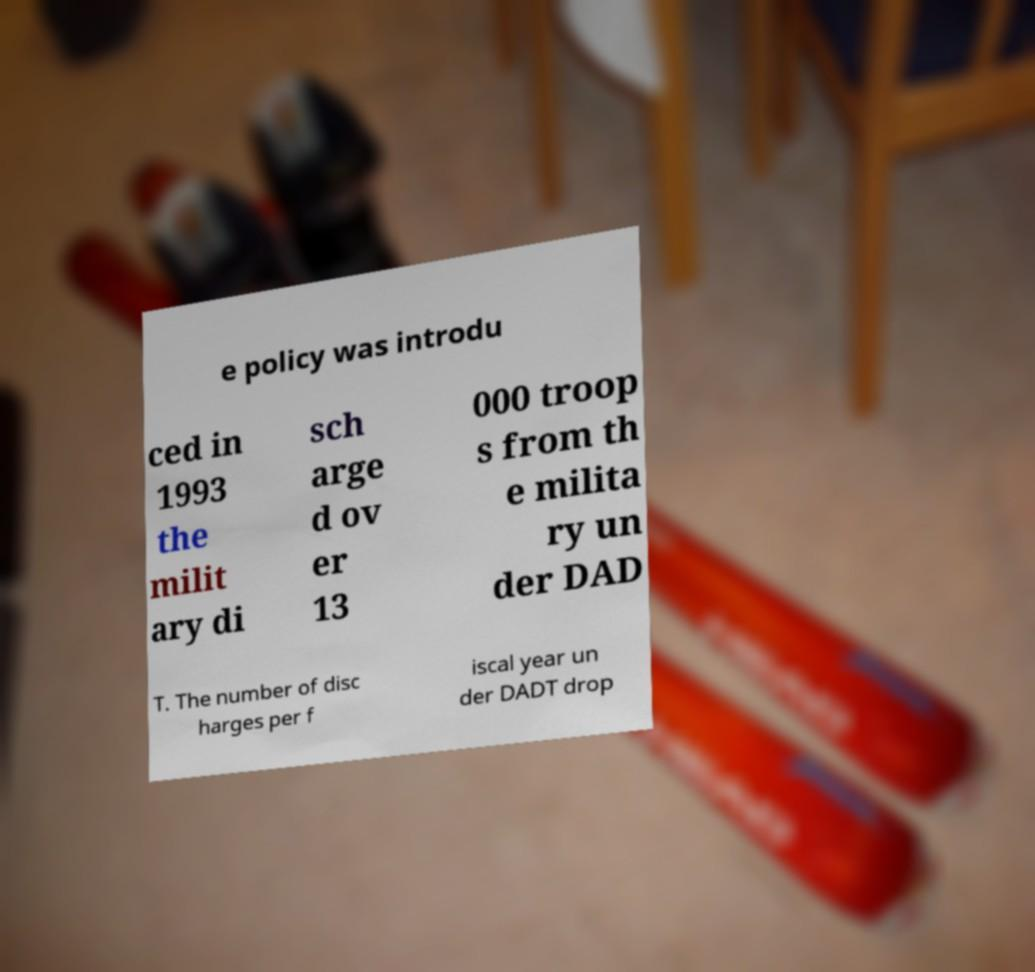Can you accurately transcribe the text from the provided image for me? e policy was introdu ced in 1993 the milit ary di sch arge d ov er 13 000 troop s from th e milita ry un der DAD T. The number of disc harges per f iscal year un der DADT drop 